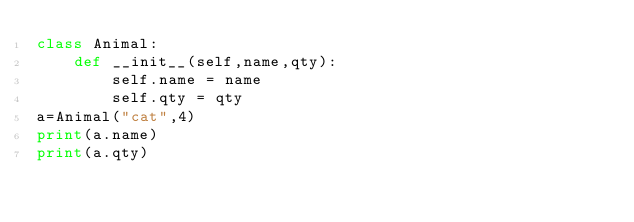Convert code to text. <code><loc_0><loc_0><loc_500><loc_500><_Python_>class Animal:
    def __init__(self,name,qty):
        self.name = name
        self.qty = qty
a=Animal("cat",4)
print(a.name)
print(a.qty)
    
</code> 